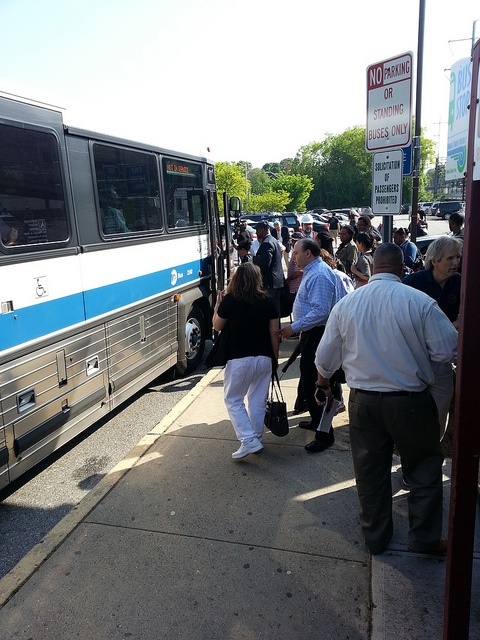Describe the objects in this image and their specific colors. I can see bus in lightblue, black, gray, white, and darkgray tones, people in lightblue, black, and gray tones, people in lightblue, black, gray, and darkgray tones, people in lightblue, black, blue, and gray tones, and people in lightblue, black, gray, and darkgray tones in this image. 